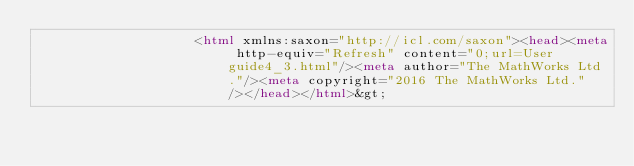Convert code to text. <code><loc_0><loc_0><loc_500><loc_500><_HTML_>                    <html xmlns:saxon="http://icl.com/saxon"><head><meta http-equiv="Refresh" content="0;url=User guide4_3.html"/><meta author="The MathWorks Ltd."/><meta copyright="2016 The MathWorks Ltd."/></head></html>&gt;
</code> 